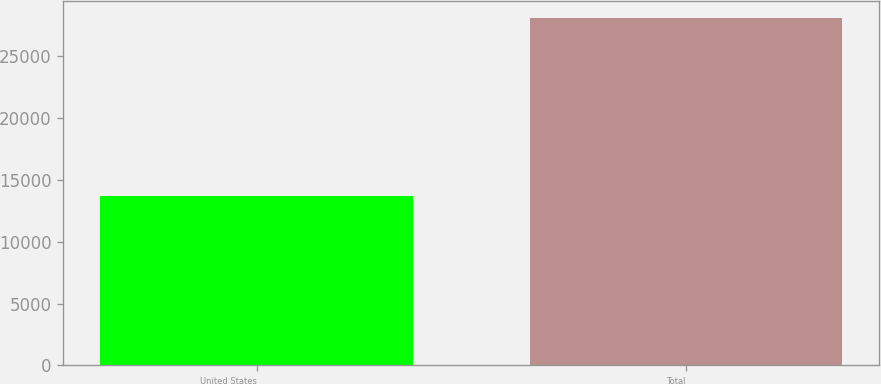Convert chart. <chart><loc_0><loc_0><loc_500><loc_500><bar_chart><fcel>United States<fcel>Total<nl><fcel>13666<fcel>28035<nl></chart> 